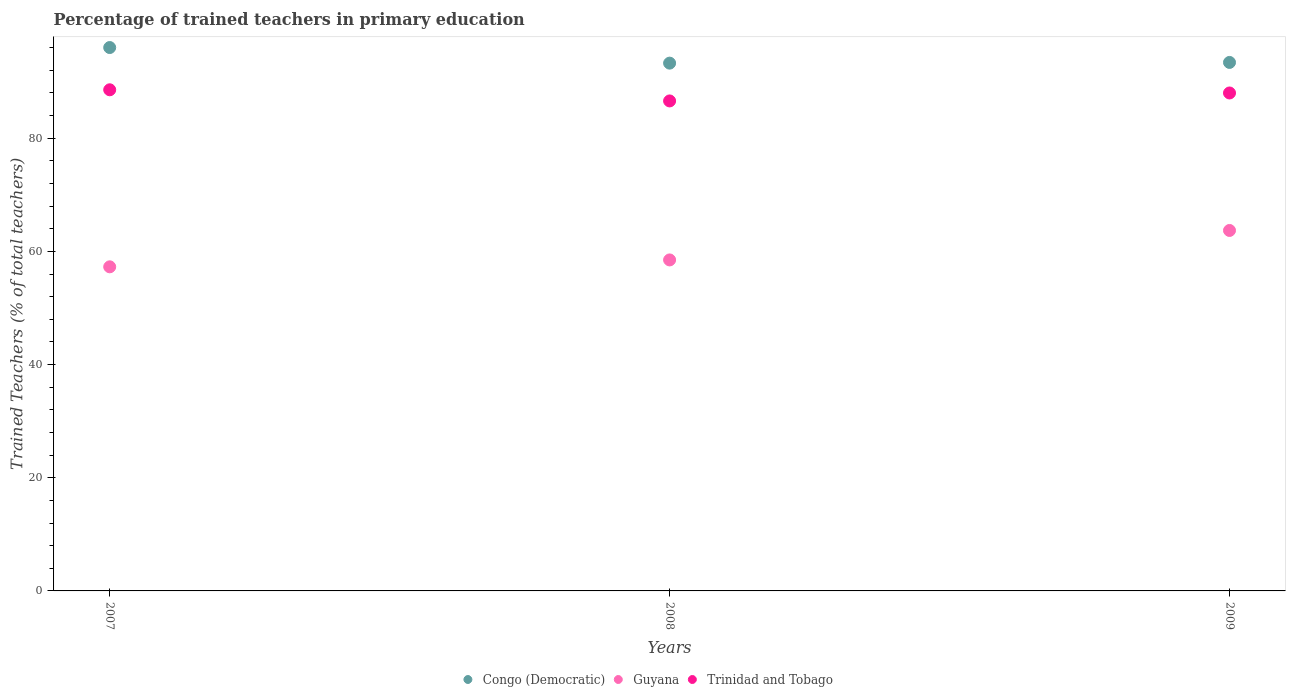What is the percentage of trained teachers in Guyana in 2007?
Your response must be concise. 57.27. Across all years, what is the maximum percentage of trained teachers in Trinidad and Tobago?
Your answer should be compact. 88.56. Across all years, what is the minimum percentage of trained teachers in Guyana?
Offer a very short reply. 57.27. In which year was the percentage of trained teachers in Guyana maximum?
Your answer should be compact. 2009. What is the total percentage of trained teachers in Congo (Democratic) in the graph?
Keep it short and to the point. 282.68. What is the difference between the percentage of trained teachers in Trinidad and Tobago in 2007 and that in 2009?
Provide a short and direct response. 0.56. What is the difference between the percentage of trained teachers in Trinidad and Tobago in 2009 and the percentage of trained teachers in Guyana in 2007?
Give a very brief answer. 30.72. What is the average percentage of trained teachers in Trinidad and Tobago per year?
Give a very brief answer. 87.71. In the year 2007, what is the difference between the percentage of trained teachers in Guyana and percentage of trained teachers in Trinidad and Tobago?
Provide a short and direct response. -31.28. What is the ratio of the percentage of trained teachers in Trinidad and Tobago in 2007 to that in 2009?
Ensure brevity in your answer.  1.01. Is the percentage of trained teachers in Trinidad and Tobago in 2007 less than that in 2009?
Your answer should be compact. No. What is the difference between the highest and the second highest percentage of trained teachers in Trinidad and Tobago?
Your response must be concise. 0.56. What is the difference between the highest and the lowest percentage of trained teachers in Guyana?
Offer a terse response. 6.43. In how many years, is the percentage of trained teachers in Guyana greater than the average percentage of trained teachers in Guyana taken over all years?
Offer a very short reply. 1. Is the sum of the percentage of trained teachers in Guyana in 2007 and 2008 greater than the maximum percentage of trained teachers in Congo (Democratic) across all years?
Your answer should be very brief. Yes. Is it the case that in every year, the sum of the percentage of trained teachers in Congo (Democratic) and percentage of trained teachers in Trinidad and Tobago  is greater than the percentage of trained teachers in Guyana?
Ensure brevity in your answer.  Yes. Does the percentage of trained teachers in Guyana monotonically increase over the years?
Make the answer very short. Yes. Is the percentage of trained teachers in Trinidad and Tobago strictly less than the percentage of trained teachers in Guyana over the years?
Your answer should be compact. No. How many years are there in the graph?
Offer a terse response. 3. What is the difference between two consecutive major ticks on the Y-axis?
Your answer should be very brief. 20. Are the values on the major ticks of Y-axis written in scientific E-notation?
Your response must be concise. No. Does the graph contain any zero values?
Ensure brevity in your answer.  No. Does the graph contain grids?
Your answer should be compact. No. Where does the legend appear in the graph?
Give a very brief answer. Bottom center. How are the legend labels stacked?
Your answer should be compact. Horizontal. What is the title of the graph?
Offer a terse response. Percentage of trained teachers in primary education. Does "Argentina" appear as one of the legend labels in the graph?
Provide a succinct answer. No. What is the label or title of the X-axis?
Offer a very short reply. Years. What is the label or title of the Y-axis?
Ensure brevity in your answer.  Trained Teachers (% of total teachers). What is the Trained Teachers (% of total teachers) of Congo (Democratic) in 2007?
Your response must be concise. 96.02. What is the Trained Teachers (% of total teachers) in Guyana in 2007?
Provide a short and direct response. 57.27. What is the Trained Teachers (% of total teachers) in Trinidad and Tobago in 2007?
Ensure brevity in your answer.  88.56. What is the Trained Teachers (% of total teachers) of Congo (Democratic) in 2008?
Your answer should be very brief. 93.27. What is the Trained Teachers (% of total teachers) of Guyana in 2008?
Your answer should be compact. 58.49. What is the Trained Teachers (% of total teachers) of Trinidad and Tobago in 2008?
Your answer should be very brief. 86.59. What is the Trained Teachers (% of total teachers) of Congo (Democratic) in 2009?
Ensure brevity in your answer.  93.39. What is the Trained Teachers (% of total teachers) of Guyana in 2009?
Provide a short and direct response. 63.7. What is the Trained Teachers (% of total teachers) in Trinidad and Tobago in 2009?
Offer a terse response. 88. Across all years, what is the maximum Trained Teachers (% of total teachers) in Congo (Democratic)?
Your answer should be very brief. 96.02. Across all years, what is the maximum Trained Teachers (% of total teachers) of Guyana?
Give a very brief answer. 63.7. Across all years, what is the maximum Trained Teachers (% of total teachers) of Trinidad and Tobago?
Keep it short and to the point. 88.56. Across all years, what is the minimum Trained Teachers (% of total teachers) in Congo (Democratic)?
Offer a very short reply. 93.27. Across all years, what is the minimum Trained Teachers (% of total teachers) in Guyana?
Provide a succinct answer. 57.27. Across all years, what is the minimum Trained Teachers (% of total teachers) of Trinidad and Tobago?
Your answer should be very brief. 86.59. What is the total Trained Teachers (% of total teachers) of Congo (Democratic) in the graph?
Ensure brevity in your answer.  282.68. What is the total Trained Teachers (% of total teachers) in Guyana in the graph?
Make the answer very short. 179.46. What is the total Trained Teachers (% of total teachers) of Trinidad and Tobago in the graph?
Provide a succinct answer. 263.14. What is the difference between the Trained Teachers (% of total teachers) in Congo (Democratic) in 2007 and that in 2008?
Your answer should be very brief. 2.76. What is the difference between the Trained Teachers (% of total teachers) of Guyana in 2007 and that in 2008?
Your answer should be very brief. -1.22. What is the difference between the Trained Teachers (% of total teachers) of Trinidad and Tobago in 2007 and that in 2008?
Offer a very short reply. 1.97. What is the difference between the Trained Teachers (% of total teachers) of Congo (Democratic) in 2007 and that in 2009?
Ensure brevity in your answer.  2.63. What is the difference between the Trained Teachers (% of total teachers) of Guyana in 2007 and that in 2009?
Your response must be concise. -6.43. What is the difference between the Trained Teachers (% of total teachers) of Trinidad and Tobago in 2007 and that in 2009?
Keep it short and to the point. 0.56. What is the difference between the Trained Teachers (% of total teachers) of Congo (Democratic) in 2008 and that in 2009?
Provide a succinct answer. -0.13. What is the difference between the Trained Teachers (% of total teachers) of Guyana in 2008 and that in 2009?
Offer a very short reply. -5.21. What is the difference between the Trained Teachers (% of total teachers) of Trinidad and Tobago in 2008 and that in 2009?
Your answer should be very brief. -1.41. What is the difference between the Trained Teachers (% of total teachers) of Congo (Democratic) in 2007 and the Trained Teachers (% of total teachers) of Guyana in 2008?
Ensure brevity in your answer.  37.53. What is the difference between the Trained Teachers (% of total teachers) of Congo (Democratic) in 2007 and the Trained Teachers (% of total teachers) of Trinidad and Tobago in 2008?
Your answer should be very brief. 9.44. What is the difference between the Trained Teachers (% of total teachers) of Guyana in 2007 and the Trained Teachers (% of total teachers) of Trinidad and Tobago in 2008?
Keep it short and to the point. -29.32. What is the difference between the Trained Teachers (% of total teachers) in Congo (Democratic) in 2007 and the Trained Teachers (% of total teachers) in Guyana in 2009?
Your response must be concise. 32.33. What is the difference between the Trained Teachers (% of total teachers) of Congo (Democratic) in 2007 and the Trained Teachers (% of total teachers) of Trinidad and Tobago in 2009?
Give a very brief answer. 8.03. What is the difference between the Trained Teachers (% of total teachers) in Guyana in 2007 and the Trained Teachers (% of total teachers) in Trinidad and Tobago in 2009?
Provide a succinct answer. -30.72. What is the difference between the Trained Teachers (% of total teachers) in Congo (Democratic) in 2008 and the Trained Teachers (% of total teachers) in Guyana in 2009?
Your response must be concise. 29.57. What is the difference between the Trained Teachers (% of total teachers) of Congo (Democratic) in 2008 and the Trained Teachers (% of total teachers) of Trinidad and Tobago in 2009?
Your answer should be very brief. 5.27. What is the difference between the Trained Teachers (% of total teachers) in Guyana in 2008 and the Trained Teachers (% of total teachers) in Trinidad and Tobago in 2009?
Ensure brevity in your answer.  -29.5. What is the average Trained Teachers (% of total teachers) in Congo (Democratic) per year?
Make the answer very short. 94.23. What is the average Trained Teachers (% of total teachers) of Guyana per year?
Offer a terse response. 59.82. What is the average Trained Teachers (% of total teachers) in Trinidad and Tobago per year?
Your answer should be very brief. 87.71. In the year 2007, what is the difference between the Trained Teachers (% of total teachers) in Congo (Democratic) and Trained Teachers (% of total teachers) in Guyana?
Keep it short and to the point. 38.75. In the year 2007, what is the difference between the Trained Teachers (% of total teachers) in Congo (Democratic) and Trained Teachers (% of total teachers) in Trinidad and Tobago?
Provide a short and direct response. 7.47. In the year 2007, what is the difference between the Trained Teachers (% of total teachers) of Guyana and Trained Teachers (% of total teachers) of Trinidad and Tobago?
Your answer should be compact. -31.28. In the year 2008, what is the difference between the Trained Teachers (% of total teachers) of Congo (Democratic) and Trained Teachers (% of total teachers) of Guyana?
Your response must be concise. 34.78. In the year 2008, what is the difference between the Trained Teachers (% of total teachers) in Congo (Democratic) and Trained Teachers (% of total teachers) in Trinidad and Tobago?
Make the answer very short. 6.68. In the year 2008, what is the difference between the Trained Teachers (% of total teachers) of Guyana and Trained Teachers (% of total teachers) of Trinidad and Tobago?
Offer a very short reply. -28.1. In the year 2009, what is the difference between the Trained Teachers (% of total teachers) in Congo (Democratic) and Trained Teachers (% of total teachers) in Guyana?
Offer a very short reply. 29.69. In the year 2009, what is the difference between the Trained Teachers (% of total teachers) of Congo (Democratic) and Trained Teachers (% of total teachers) of Trinidad and Tobago?
Provide a short and direct response. 5.4. In the year 2009, what is the difference between the Trained Teachers (% of total teachers) of Guyana and Trained Teachers (% of total teachers) of Trinidad and Tobago?
Offer a terse response. -24.3. What is the ratio of the Trained Teachers (% of total teachers) of Congo (Democratic) in 2007 to that in 2008?
Offer a very short reply. 1.03. What is the ratio of the Trained Teachers (% of total teachers) of Guyana in 2007 to that in 2008?
Provide a short and direct response. 0.98. What is the ratio of the Trained Teachers (% of total teachers) in Trinidad and Tobago in 2007 to that in 2008?
Provide a succinct answer. 1.02. What is the ratio of the Trained Teachers (% of total teachers) of Congo (Democratic) in 2007 to that in 2009?
Provide a succinct answer. 1.03. What is the ratio of the Trained Teachers (% of total teachers) of Guyana in 2007 to that in 2009?
Your response must be concise. 0.9. What is the ratio of the Trained Teachers (% of total teachers) of Trinidad and Tobago in 2007 to that in 2009?
Your response must be concise. 1.01. What is the ratio of the Trained Teachers (% of total teachers) of Guyana in 2008 to that in 2009?
Offer a very short reply. 0.92. What is the difference between the highest and the second highest Trained Teachers (% of total teachers) in Congo (Democratic)?
Make the answer very short. 2.63. What is the difference between the highest and the second highest Trained Teachers (% of total teachers) of Guyana?
Your answer should be compact. 5.21. What is the difference between the highest and the second highest Trained Teachers (% of total teachers) in Trinidad and Tobago?
Offer a terse response. 0.56. What is the difference between the highest and the lowest Trained Teachers (% of total teachers) of Congo (Democratic)?
Provide a short and direct response. 2.76. What is the difference between the highest and the lowest Trained Teachers (% of total teachers) of Guyana?
Your response must be concise. 6.43. What is the difference between the highest and the lowest Trained Teachers (% of total teachers) of Trinidad and Tobago?
Provide a succinct answer. 1.97. 